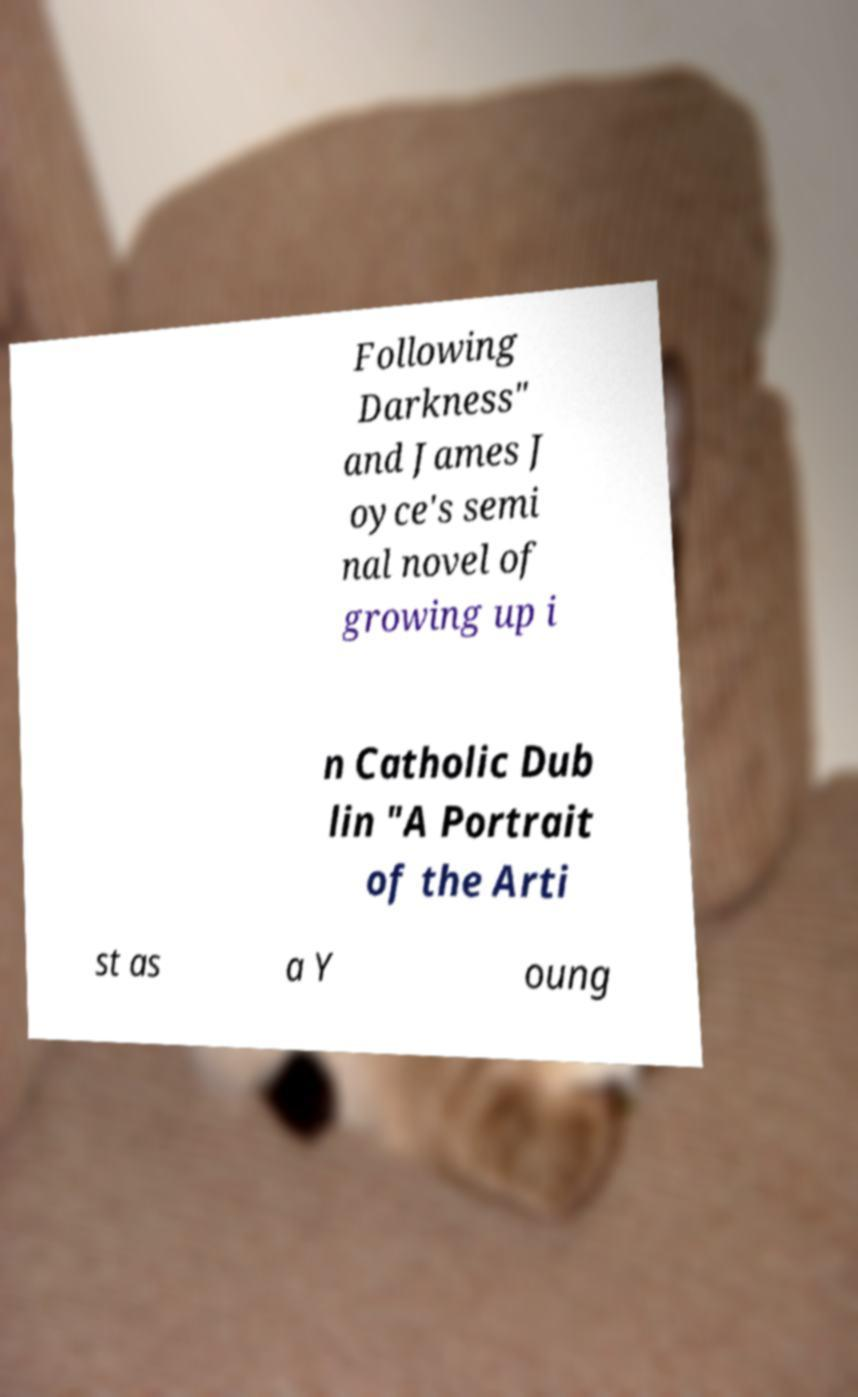Please identify and transcribe the text found in this image. Following Darkness" and James J oyce's semi nal novel of growing up i n Catholic Dub lin "A Portrait of the Arti st as a Y oung 